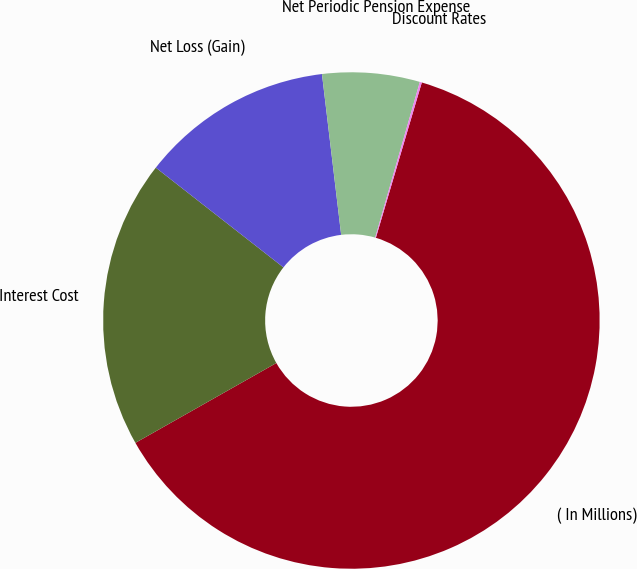Convert chart. <chart><loc_0><loc_0><loc_500><loc_500><pie_chart><fcel>( In Millions)<fcel>Interest Cost<fcel>Net Loss (Gain)<fcel>Net Periodic Pension Expense<fcel>Discount Rates<nl><fcel>62.22%<fcel>18.76%<fcel>12.55%<fcel>6.34%<fcel>0.13%<nl></chart> 